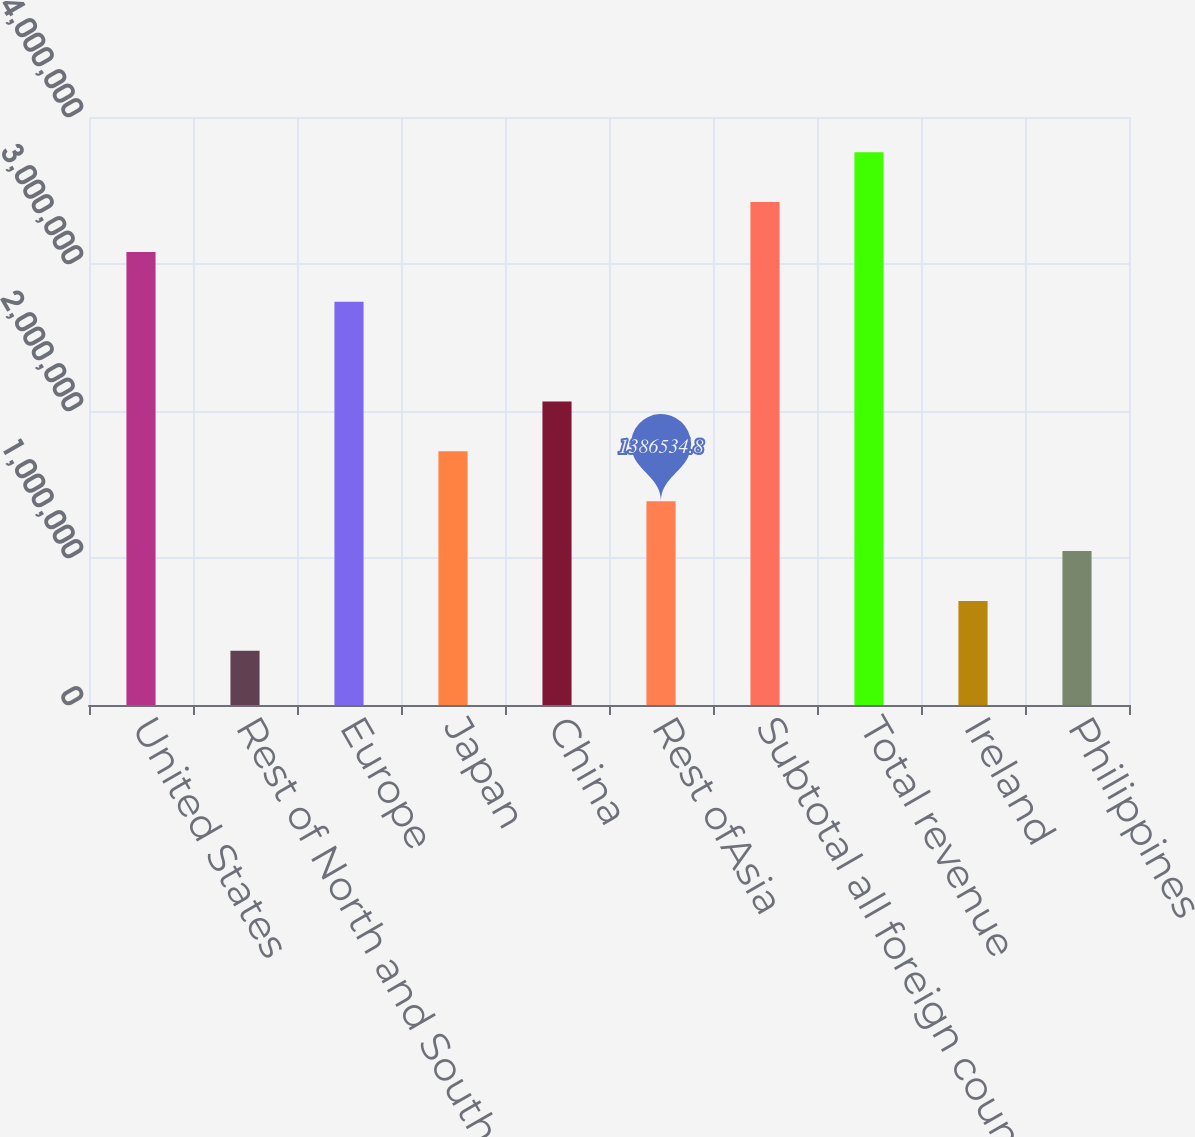Convert chart. <chart><loc_0><loc_0><loc_500><loc_500><bar_chart><fcel>United States<fcel>Rest of North and South<fcel>Europe<fcel>Japan<fcel>China<fcel>Rest ofAsia<fcel>Subtotal all foreign countries<fcel>Total revenue<fcel>Ireland<fcel>Philippines<nl><fcel>3.08226e+06<fcel>369098<fcel>2.74312e+06<fcel>1.72568e+06<fcel>2.06483e+06<fcel>1.38653e+06<fcel>3.42141e+06<fcel>3.76055e+06<fcel>708243<fcel>1.04739e+06<nl></chart> 